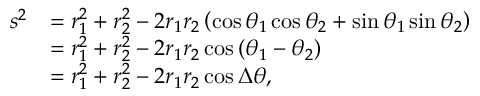<formula> <loc_0><loc_0><loc_500><loc_500>{ \begin{array} { r l } { s ^ { 2 } } & { = r _ { 1 } ^ { 2 } + r _ { 2 } ^ { 2 } - 2 r _ { 1 } r _ { 2 } \left ( \cos \theta _ { 1 } \cos \theta _ { 2 } + \sin \theta _ { 1 } \sin \theta _ { 2 } \right ) } \\ & { = r _ { 1 } ^ { 2 } + r _ { 2 } ^ { 2 } - 2 r _ { 1 } r _ { 2 } \cos \left ( \theta _ { 1 } - \theta _ { 2 } \right ) } \\ & { = r _ { 1 } ^ { 2 } + r _ { 2 } ^ { 2 } - 2 r _ { 1 } r _ { 2 } \cos \Delta \theta , } \end{array} }</formula> 